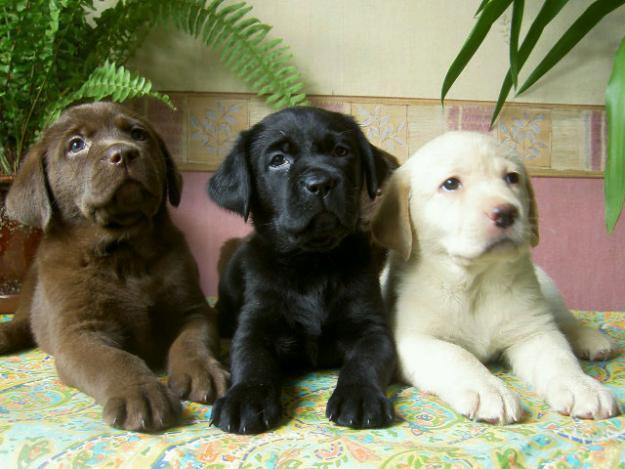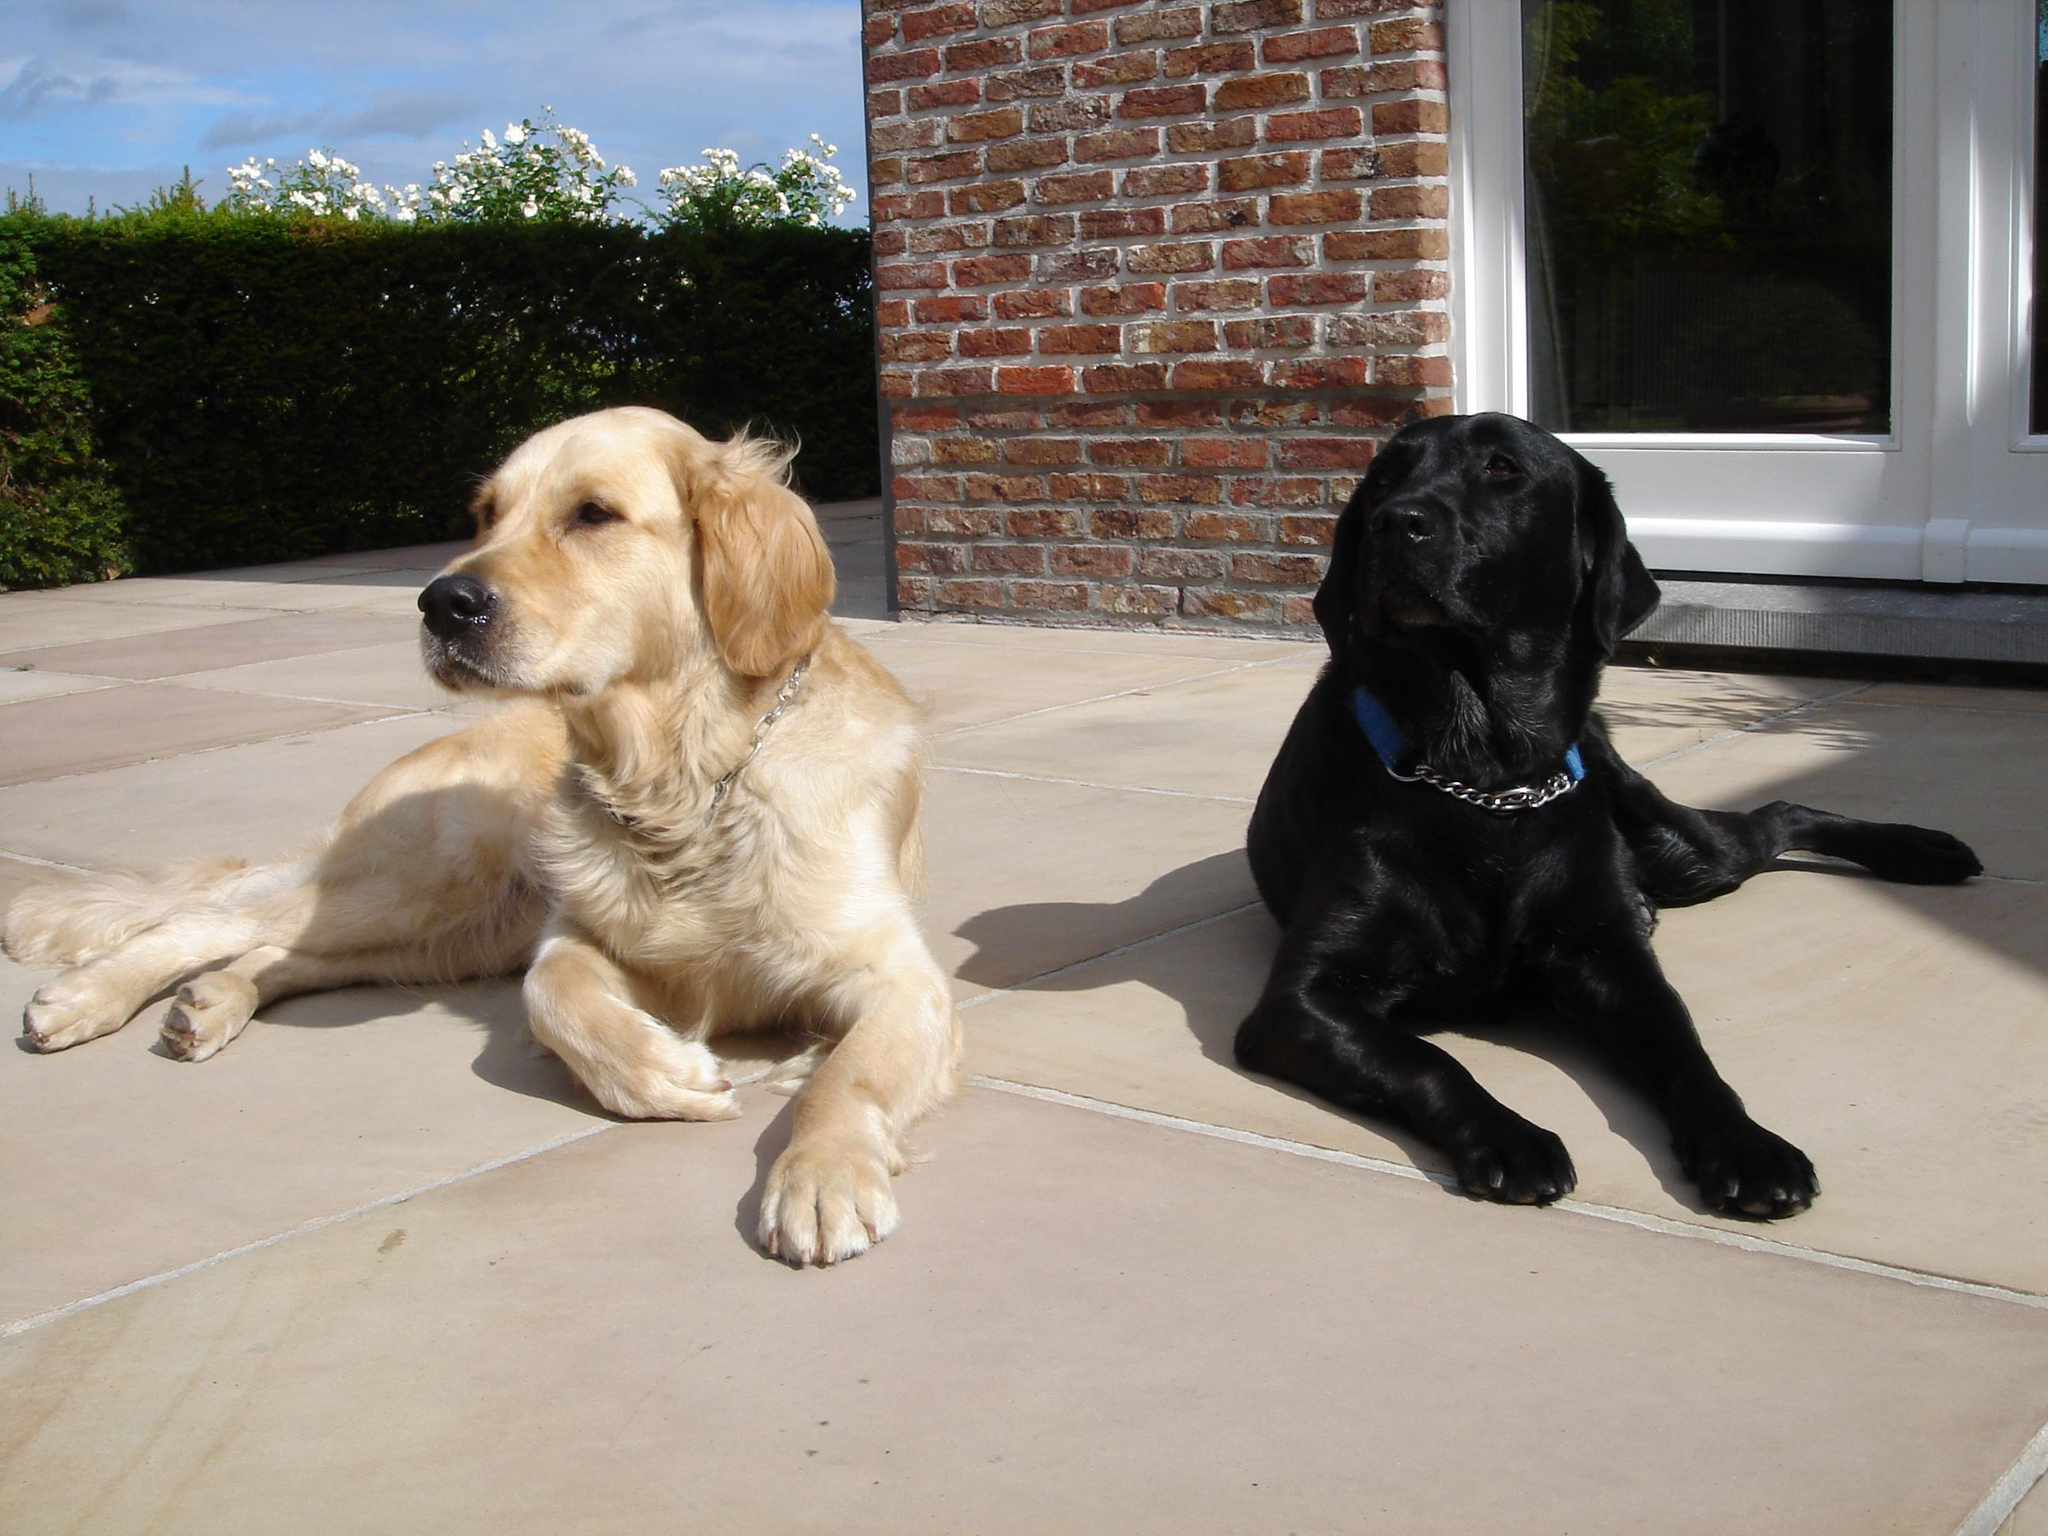The first image is the image on the left, the second image is the image on the right. Assess this claim about the two images: "The right image contains two dogs that are different colors.". Correct or not? Answer yes or no. Yes. 